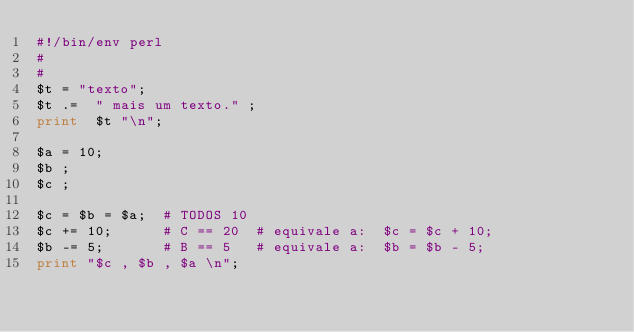Convert code to text. <code><loc_0><loc_0><loc_500><loc_500><_Perl_>#!/bin/env perl
#
#
$t = "texto";
$t .=  " mais um texto." ;
print  $t "\n";

$a = 10;
$b ;
$c ;

$c = $b = $a;  # TODOS 10
$c += 10;      # C == 20  # equivale a:  $c = $c + 10;
$b -= 5;       # B == 5   # equivale a:  $b = $b - 5;
print "$c , $b , $a \n";


</code> 